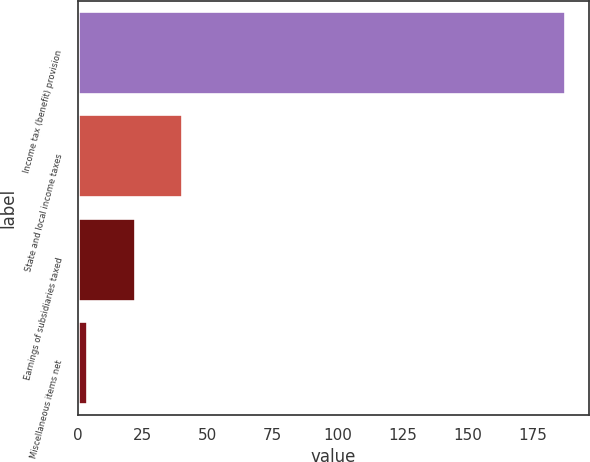Convert chart. <chart><loc_0><loc_0><loc_500><loc_500><bar_chart><fcel>Income tax (benefit) provision<fcel>State and local income taxes<fcel>Earnings of subsidiaries taxed<fcel>Miscellaneous items net<nl><fcel>187.3<fcel>40.34<fcel>21.97<fcel>3.6<nl></chart> 